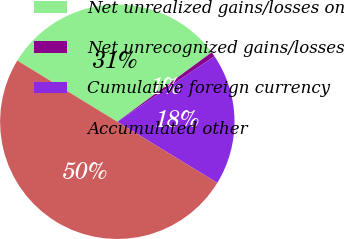Convert chart to OTSL. <chart><loc_0><loc_0><loc_500><loc_500><pie_chart><fcel>Net unrealized gains/losses on<fcel>Net unrecognized gains/losses<fcel>Cumulative foreign currency<fcel>Accumulated other<nl><fcel>31.17%<fcel>0.65%<fcel>18.18%<fcel>50.0%<nl></chart> 